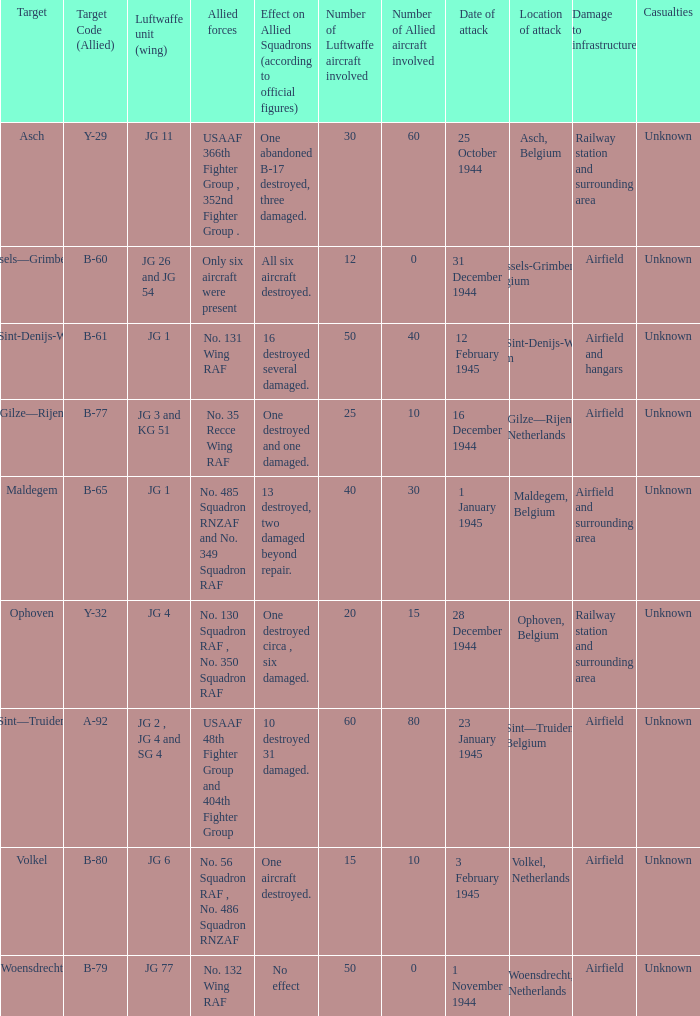Would you be able to parse every entry in this table? {'header': ['Target', 'Target Code (Allied)', 'Luftwaffe unit (wing)', 'Allied forces', 'Effect on Allied Squadrons (according to official figures)', 'Number of Luftwaffe aircraft involved', 'Number of Allied aircraft involved', 'Date of attack', 'Location of attack', 'Damage to infrastructure', 'Casualties'], 'rows': [['Asch', 'Y-29', 'JG 11', 'USAAF 366th Fighter Group , 352nd Fighter Group .', 'One abandoned B-17 destroyed, three damaged.', '30', '60', '25 October 1944', 'Asch, Belgium', 'Railway station and surrounding area', 'Unknown'], ['Brussels—Grimbergen', 'B-60', 'JG 26 and JG 54', 'Only six aircraft were present', 'All six aircraft destroyed.', '12', '0', '31 December 1944', 'Brussels-Grimbergen, Belgium', 'Airfield', 'Unknown'], ['Ghent/Sint-Denijs-Westrem', 'B-61', 'JG 1', 'No. 131 Wing RAF', '16 destroyed several damaged.', '50', '40', '12 February 1945', 'Ghent/Sint-Denijs-Westrem, Belgium', 'Airfield and hangars', 'Unknown'], ['Gilze—Rijen', 'B-77', 'JG 3 and KG 51', 'No. 35 Recce Wing RAF', 'One destroyed and one damaged.', '25', '10', '16 December 1944', 'Gilze—Rijen, Netherlands', 'Airfield', 'Unknown'], ['Maldegem', 'B-65', 'JG 1', 'No. 485 Squadron RNZAF and No. 349 Squadron RAF', '13 destroyed, two damaged beyond repair.', '40', '30', '1 January 1945', 'Maldegem, Belgium', 'Airfield and surrounding area', 'Unknown'], ['Ophoven', 'Y-32', 'JG 4', 'No. 130 Squadron RAF , No. 350 Squadron RAF', 'One destroyed circa , six damaged.', '20', '15', '28 December 1944', 'Ophoven, Belgium', 'Railway station and surrounding area', 'Unknown'], ['Sint—Truiden', 'A-92', 'JG 2 , JG 4 and SG 4', 'USAAF 48th Fighter Group and 404th Fighter Group', '10 destroyed 31 damaged.', '60', '80', '23 January 1945', 'Sint—Truiden, Belgium', 'Airfield', 'Unknown'], ['Volkel', 'B-80', 'JG 6', 'No. 56 Squadron RAF , No. 486 Squadron RNZAF', 'One aircraft destroyed.', '15', '10', '3 February 1945', 'Volkel, Netherlands', 'Airfield', 'Unknown'], ['Woensdrecht', 'B-79', 'JG 77', 'No. 132 Wing RAF', 'No effect', '50', '0', '1 November 1944', 'Woensdrecht, Netherlands', 'Airfield', 'Unknown']]} What is the allied target code of the group that targetted ghent/sint-denijs-westrem? B-61. 